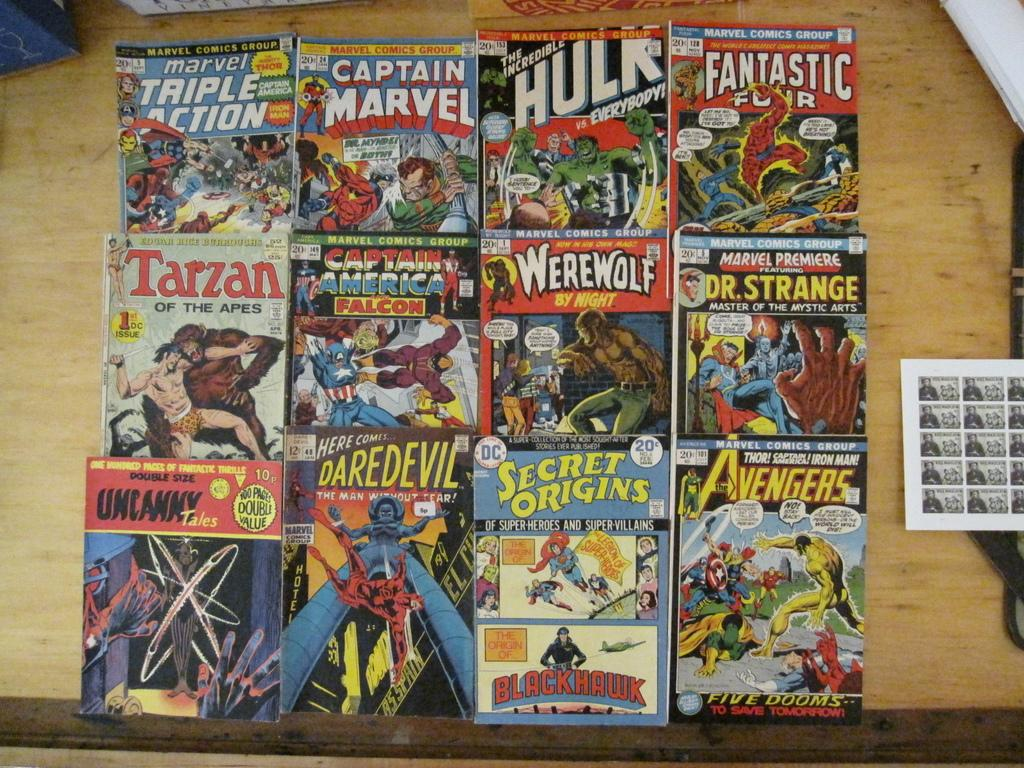<image>
Give a short and clear explanation of the subsequent image. Many comic books including The Incredible Hulk are laid out on a wooden surface. 